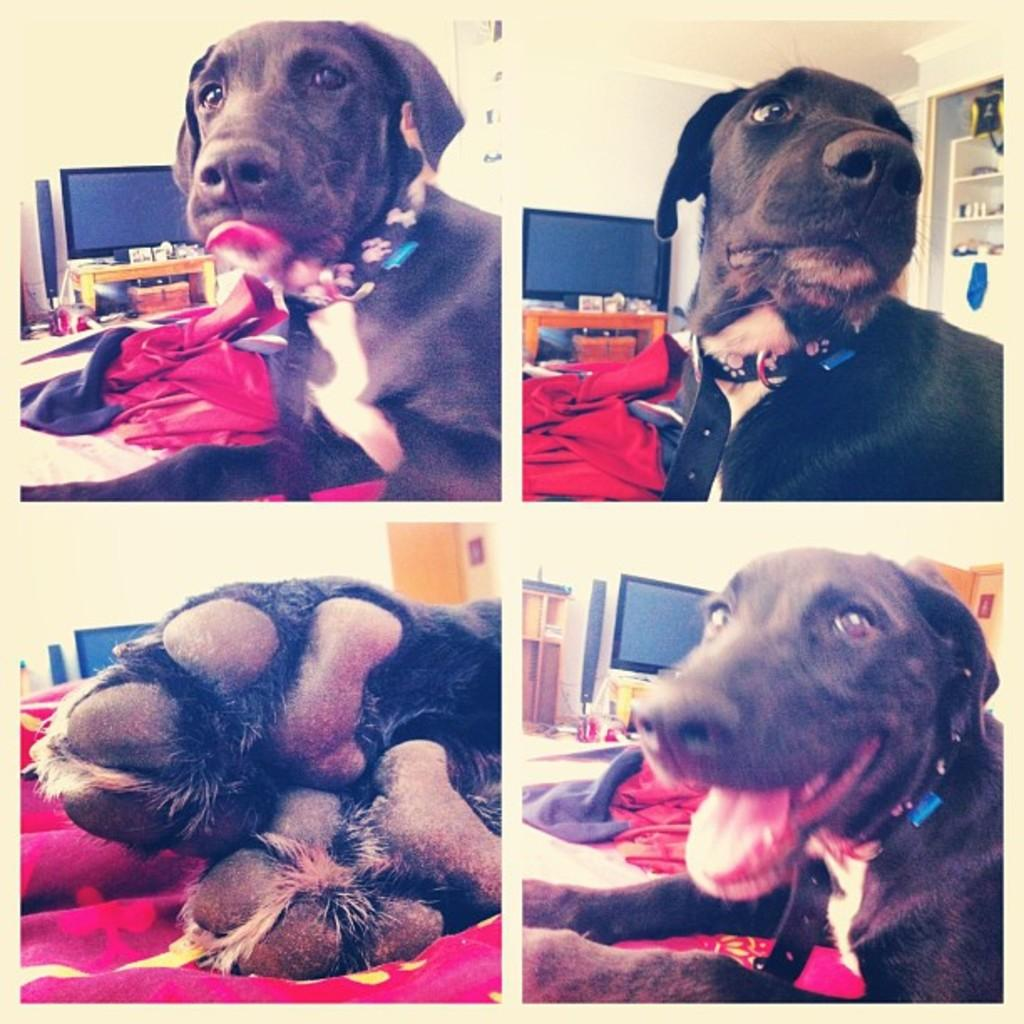What animal can be seen sitting on the bed in one of the pictures? There is a dog sitting on the bed in one of the pictures. What electronic device is present on a table in one of the pictures? There is a computer on a table in one of the pictures. What type of plant is visible on the computer screen in one of the pictures? There is no plant visible on the computer screen in the pictures; the computer is the only electronic device mentioned. 